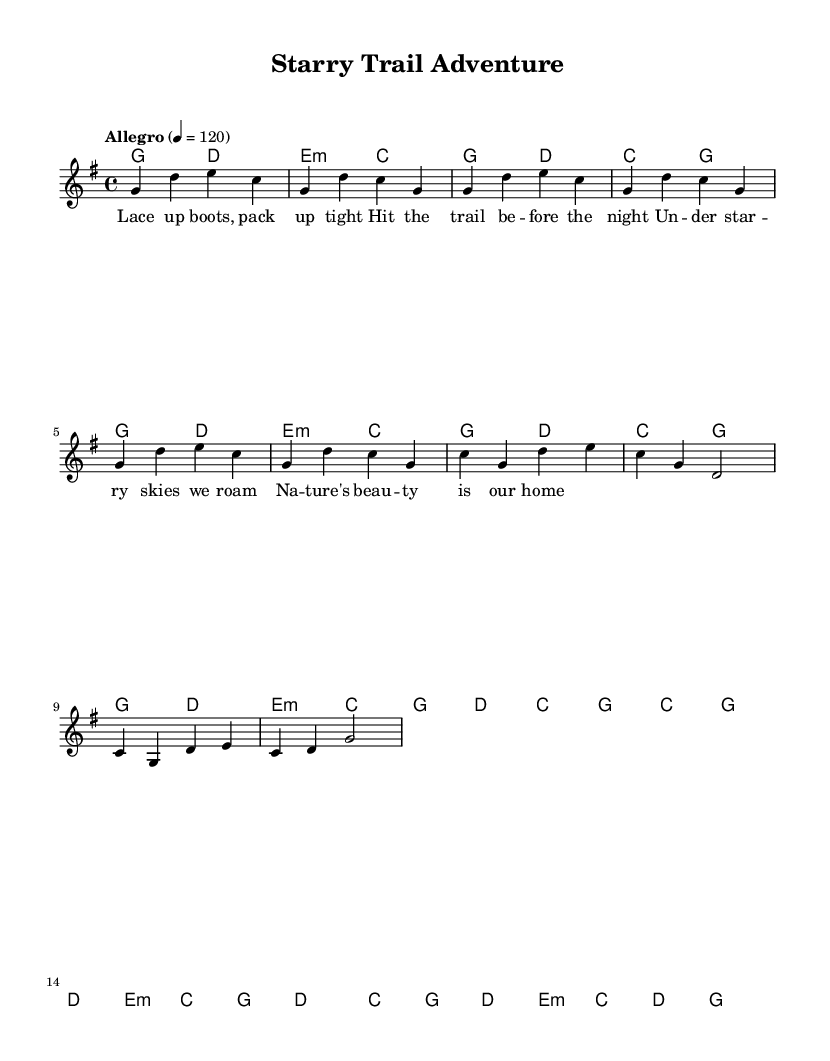What is the key signature of this music? The key signature indicates that the music is in G major, which has one sharp (F#). This can be determined from the key signature notation at the beginning of the score.
Answer: G major What is the time signature of the piece? The time signature shown at the beginning of the music is 4/4, meaning there are four beats in each measure and the quarter note gets one beat. This can be identified by the fraction displayed in the header section of the score.
Answer: 4/4 What is the tempo marking for this piece? The tempo marking at the top of the score states "Allegro" and specifies a speed of 120 beats per minute, indicating a fast and lively tempo. This can be found right after the time signature.
Answer: Allegro, 120 How many measures are in the chorus section? By analyzing the measures in the chorus section of the score, it can be seen that there are four measures in total. Each measure is marked by vertical lines, making it straightforward to count.
Answer: 4 What is the first line of the lyrics? The first line of the lyrics is "Lace up boots, pack up tight." This can be identified from the lyric section aligned with the melody notes of the first verse in the score.
Answer: Lace up boots, pack up tight What chords accompany the chorus? The chords that accompany the chorus are C, G, D, and E minor. By looking at the chord names section aligned with the chorus melody notes, these chords can be directly identified.
Answer: C, G, D, E minor What is the form of the song? The form of the song can be classified as Verse-Chorus, as there is a distinct verse followed by a recurring chorus, a common structure in folk songs. This can be deduced from the layout of the lyrics and sections in the score.
Answer: Verse-Chorus 